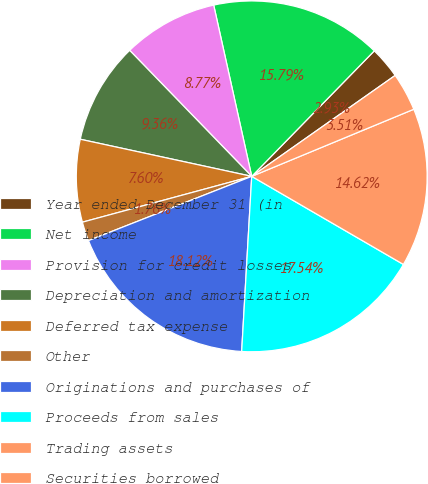Convert chart. <chart><loc_0><loc_0><loc_500><loc_500><pie_chart><fcel>Year ended December 31 (in<fcel>Net income<fcel>Provision for credit losses<fcel>Depreciation and amortization<fcel>Deferred tax expense<fcel>Other<fcel>Originations and purchases of<fcel>Proceeds from sales<fcel>Trading assets<fcel>Securities borrowed<nl><fcel>2.93%<fcel>15.79%<fcel>8.77%<fcel>9.36%<fcel>7.6%<fcel>1.76%<fcel>18.12%<fcel>17.54%<fcel>14.62%<fcel>3.51%<nl></chart> 